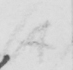Please provide the text content of this handwritten line. (A) 